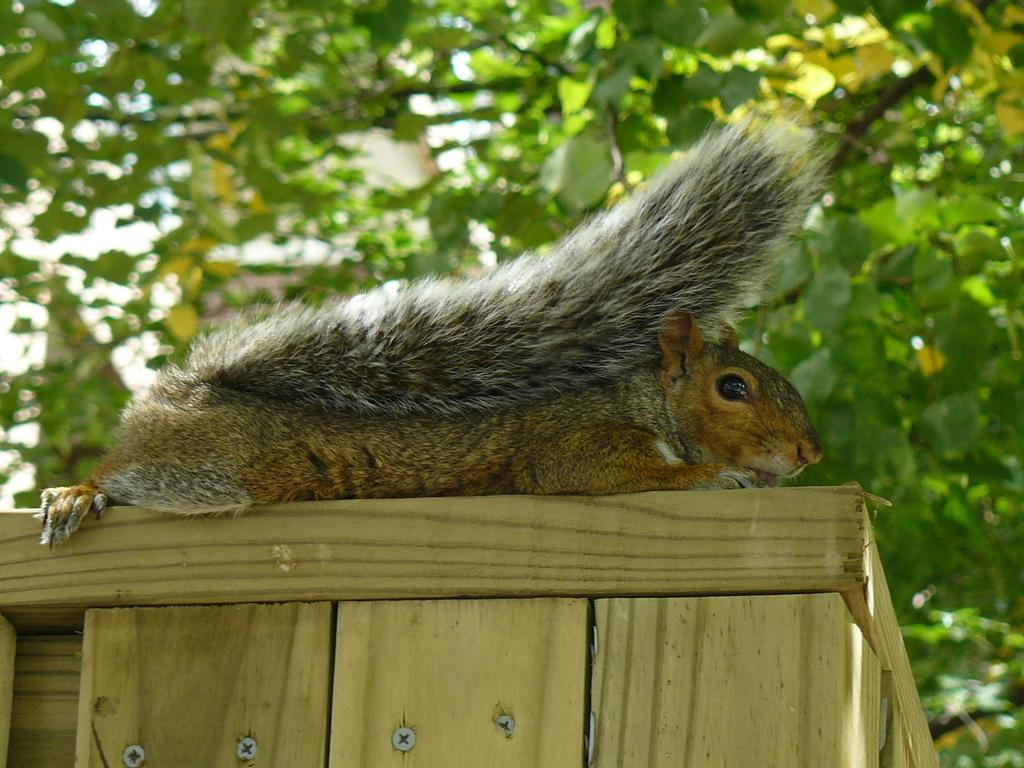What animal is on the table in the image? There is a squirrel on the table in the image. What type of vegetation is visible in the background of the image? There is a tree at the back side of the image. What type of celery is the squirrel holding in the image? There is no celery present in the image; the squirrel is not holding anything. 